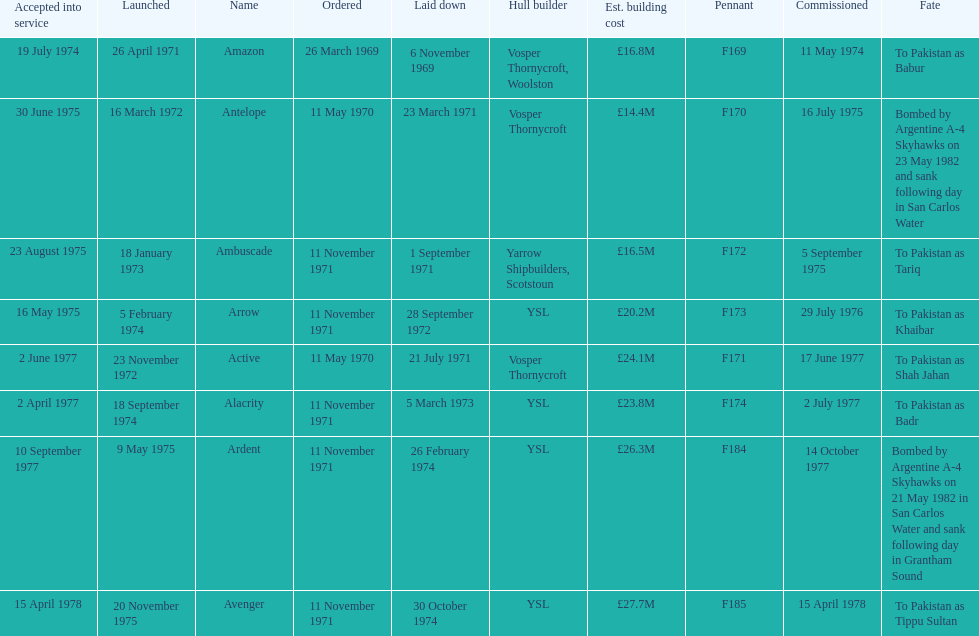The arrow was ordered on november 11, 1971. what was the previous ship? Ambuscade. 